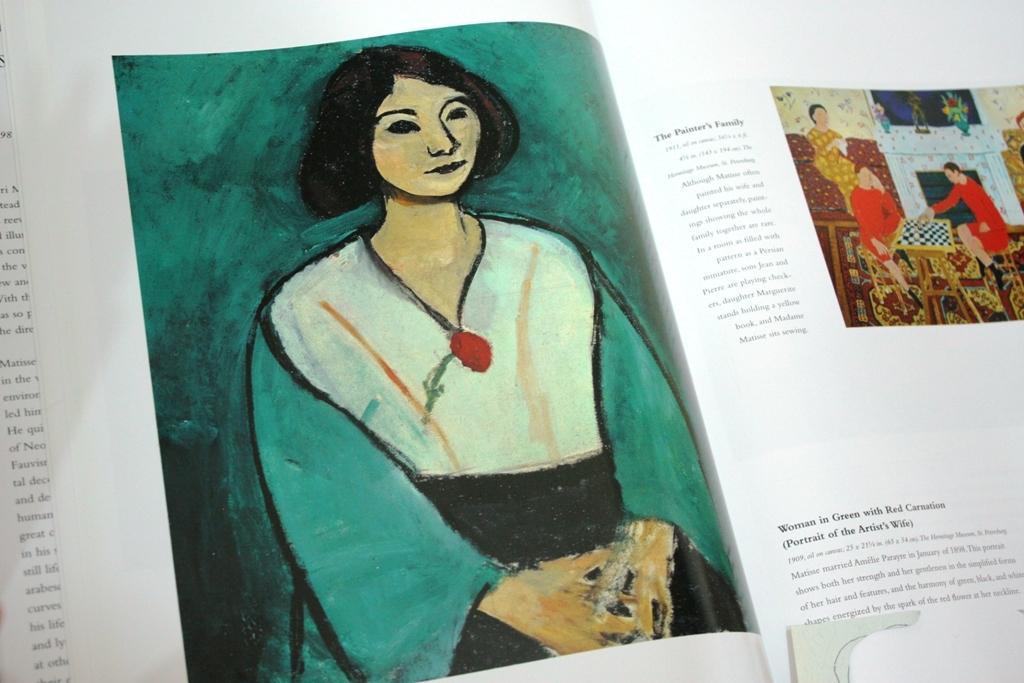Could you give a brief overview of what you see in this image? In the image in the center we can see one book. On the book,we can see one person standing and few people were sitting. And we can see something written on the paper. 